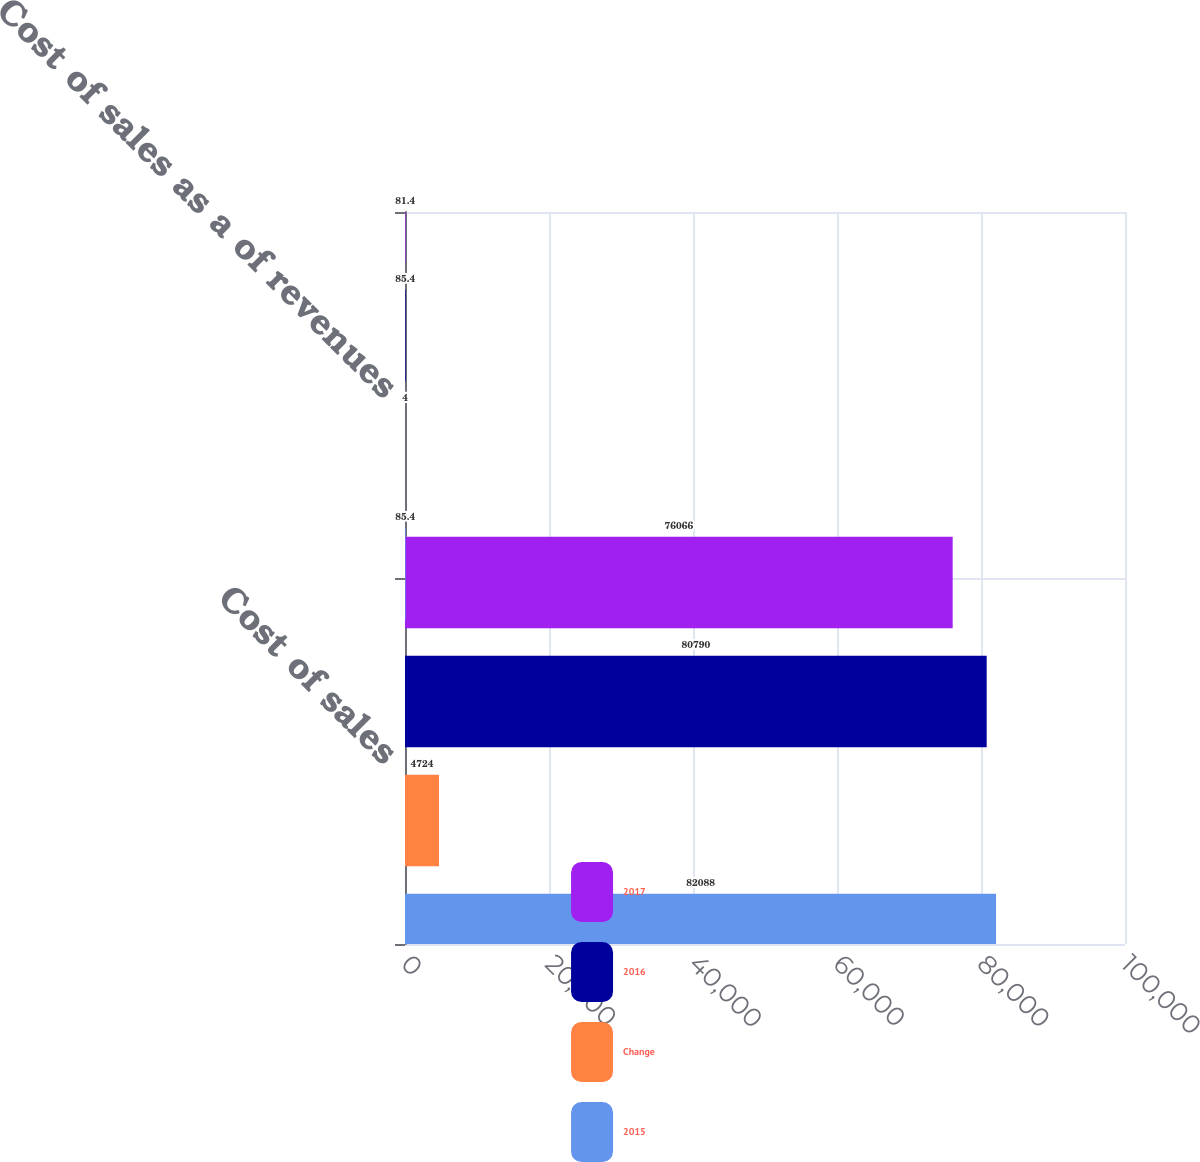Convert chart. <chart><loc_0><loc_0><loc_500><loc_500><stacked_bar_chart><ecel><fcel>Cost of sales<fcel>Cost of sales as a of revenues<nl><fcel>2017<fcel>76066<fcel>81.4<nl><fcel>2016<fcel>80790<fcel>85.4<nl><fcel>Change<fcel>4724<fcel>4<nl><fcel>2015<fcel>82088<fcel>85.4<nl></chart> 